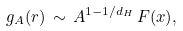Convert formula to latex. <formula><loc_0><loc_0><loc_500><loc_500>g _ { A } ( r ) \, \sim \, A ^ { 1 - 1 / d _ { H } } \, F ( x ) ,</formula> 